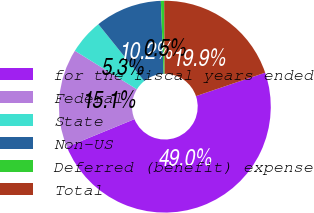Convert chart. <chart><loc_0><loc_0><loc_500><loc_500><pie_chart><fcel>for the fiscal years ended<fcel>Federal<fcel>State<fcel>Non-US<fcel>Deferred (benefit) expense<fcel>Total<nl><fcel>49.0%<fcel>15.05%<fcel>5.35%<fcel>10.2%<fcel>0.5%<fcel>19.9%<nl></chart> 